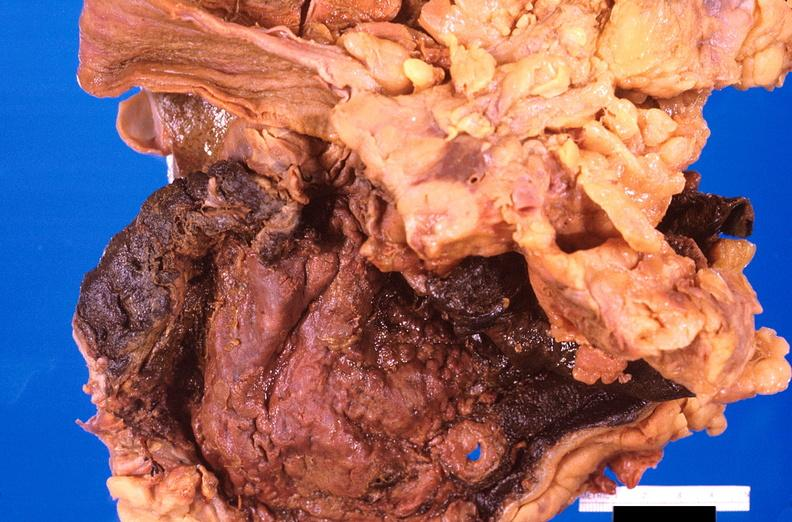what is stomach , necrotizing esophagitis and gastritis , sulfuric acid ingested?
Answer the question using a single word or phrase. As suicide attempt 